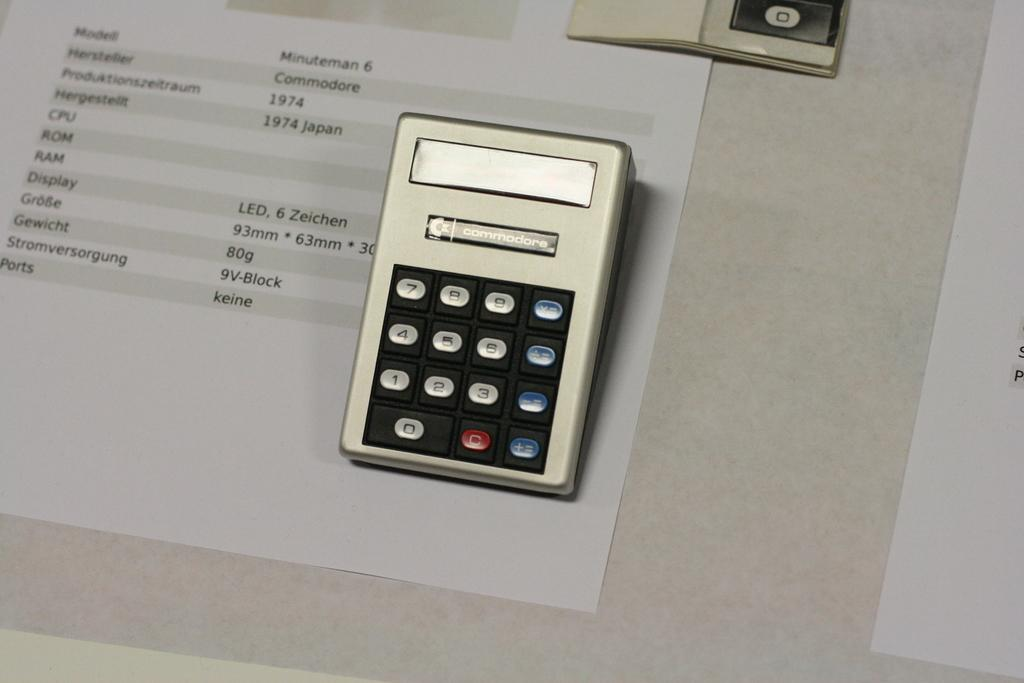<image>
Share a concise interpretation of the image provided. A small calculator is on a board with a paper that is about the minuteman 6. 